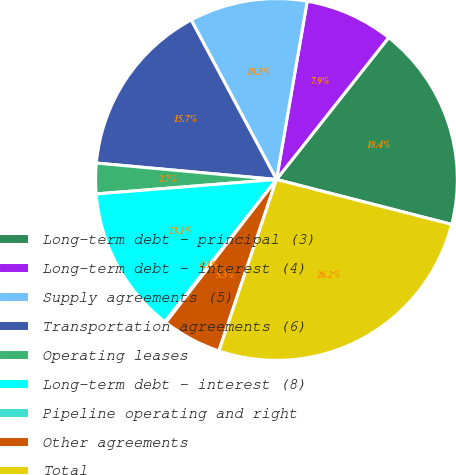Convert chart. <chart><loc_0><loc_0><loc_500><loc_500><pie_chart><fcel>Long-term debt - principal (3)<fcel>Long-term debt - interest (4)<fcel>Supply agreements (5)<fcel>Transportation agreements (6)<fcel>Operating leases<fcel>Long-term debt - interest (8)<fcel>Pipeline operating and right<fcel>Other agreements<fcel>Total<nl><fcel>18.35%<fcel>7.93%<fcel>10.53%<fcel>15.74%<fcel>2.72%<fcel>13.14%<fcel>0.11%<fcel>5.32%<fcel>26.16%<nl></chart> 